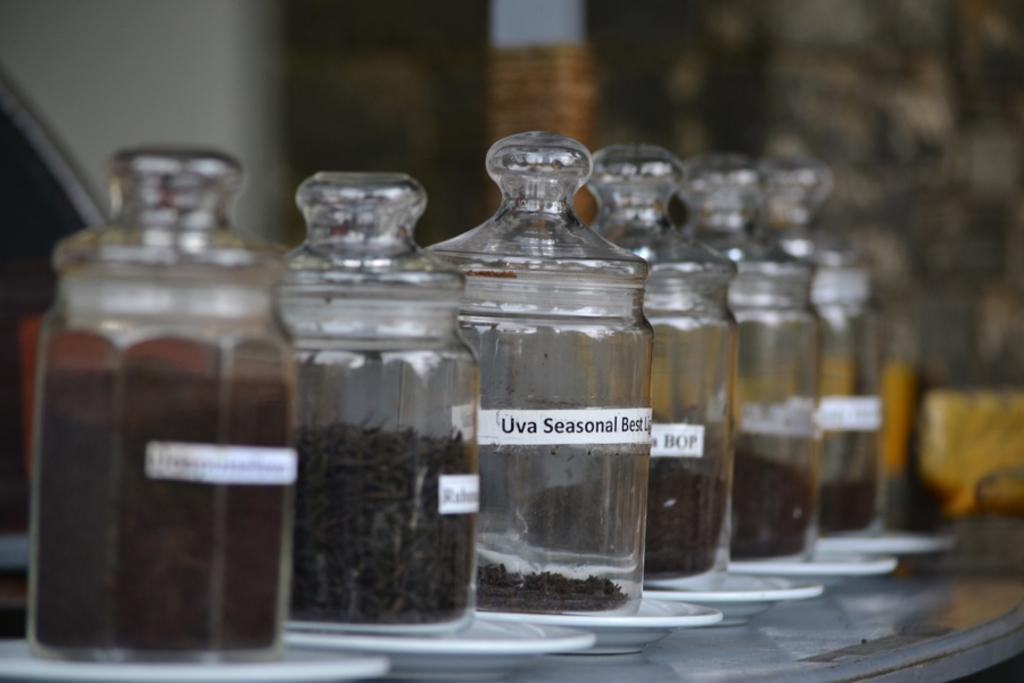<image>
Offer a succinct explanation of the picture presented. A row of small jars with lids with various coffees with one labeled Uva Seasonal Best. 